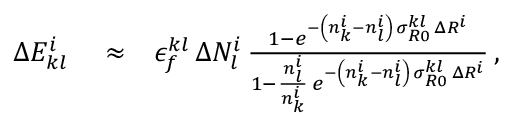Convert formula to latex. <formula><loc_0><loc_0><loc_500><loc_500>\begin{array} { r l r } { \Delta E _ { k l } ^ { i } } & \approx } & { \epsilon _ { f } ^ { k l } \, \Delta N _ { l } ^ { i } \, \frac { 1 - e ^ { - \left ( n _ { k } ^ { i } - n _ { l } ^ { i } \right ) \, \sigma _ { R 0 } ^ { k l } \, \Delta R ^ { i } } } { 1 - \frac { n _ { l } ^ { i } } { n _ { k } ^ { i } } \, e ^ { - \left ( n _ { k } ^ { i } - n _ { l } ^ { i } \right ) \, \sigma _ { R 0 } ^ { k l } \, \Delta R ^ { i } } } \, , } \end{array}</formula> 